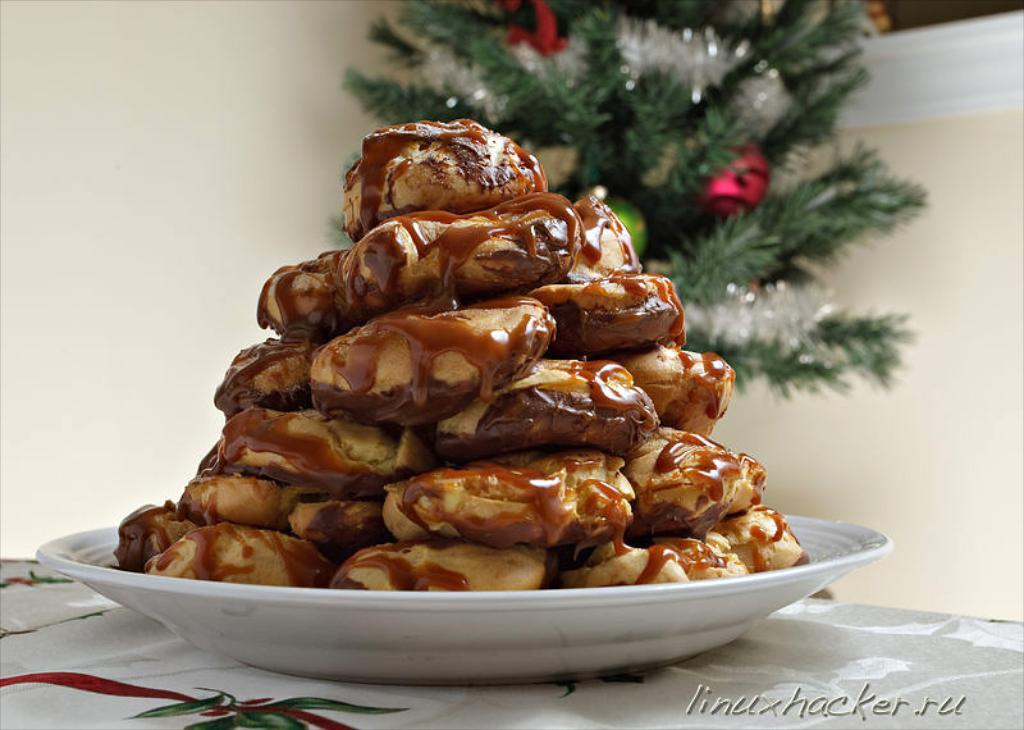What is on the plate that is visible in the image? There is food on a plate in the image. Where is the plate located in the image? The plate is on a table in the image. What can be seen in front of the wall in the image? There is a Christmas tree in front of a wall in the image. What is present in the bottom right of the image? There is a text in the bottom right of the image. Where is the pan used for cooking the food in the image? There is no pan visible in the image, as it only shows a plate of food on a table. 